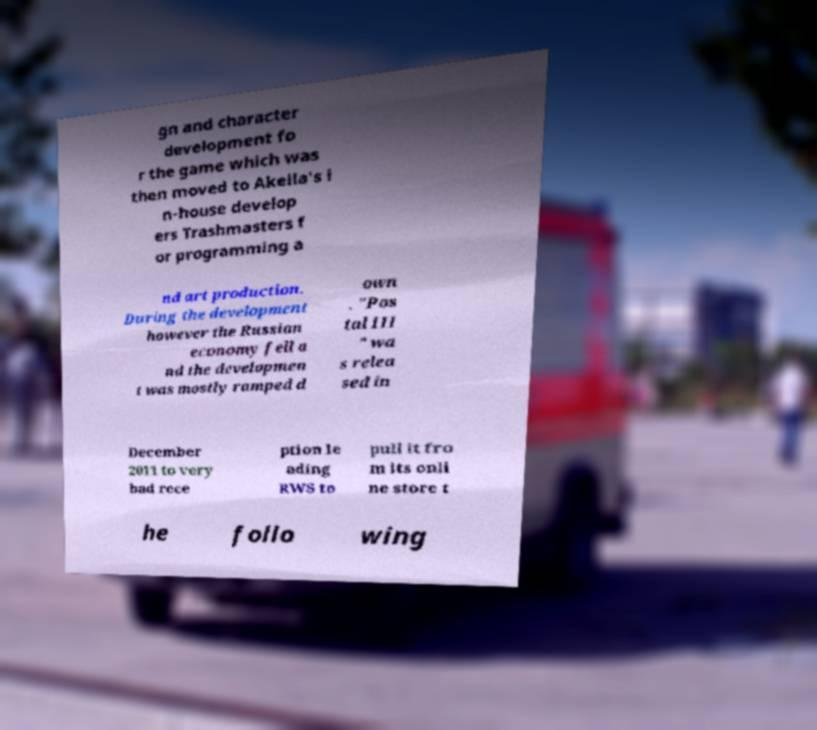Please identify and transcribe the text found in this image. gn and character development fo r the game which was then moved to Akella's i n-house develop ers Trashmasters f or programming a nd art production. During the development however the Russian economy fell a nd the developmen t was mostly ramped d own . "Pos tal III " wa s relea sed in December 2011 to very bad rece ption le ading RWS to pull it fro m its onli ne store t he follo wing 